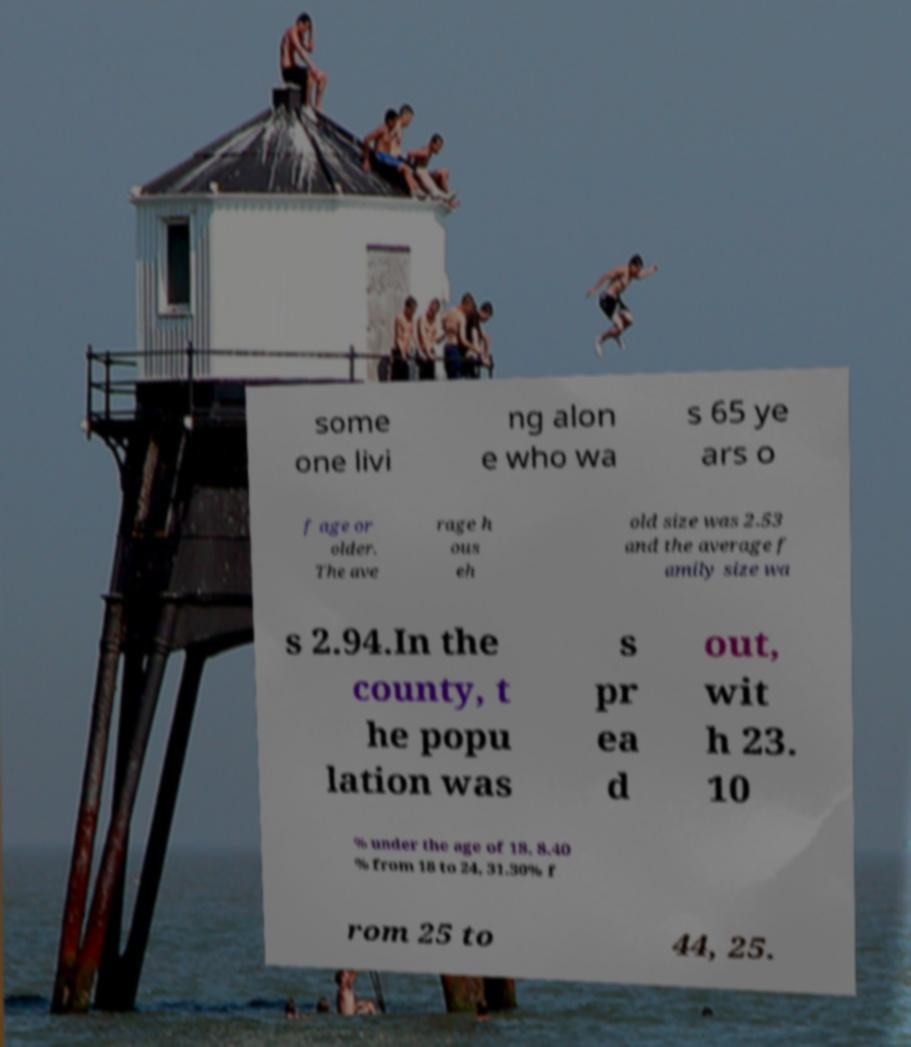Please read and relay the text visible in this image. What does it say? some one livi ng alon e who wa s 65 ye ars o f age or older. The ave rage h ous eh old size was 2.53 and the average f amily size wa s 2.94.In the county, t he popu lation was s pr ea d out, wit h 23. 10 % under the age of 18, 8.40 % from 18 to 24, 31.30% f rom 25 to 44, 25. 